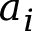<formula> <loc_0><loc_0><loc_500><loc_500>a _ { i }</formula> 